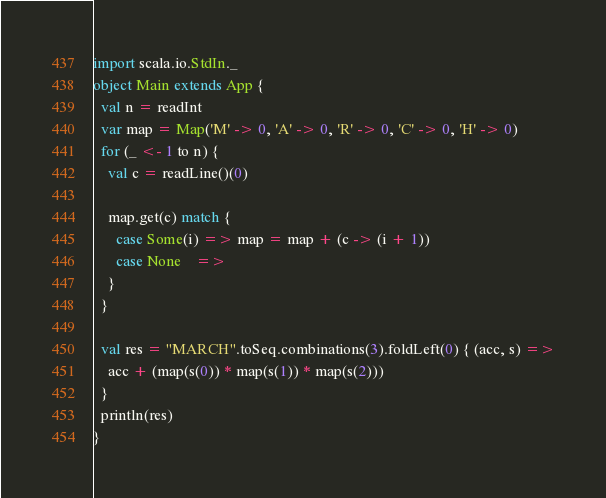<code> <loc_0><loc_0><loc_500><loc_500><_Scala_>import scala.io.StdIn._
object Main extends App {
  val n = readInt
  var map = Map('M' -> 0, 'A' -> 0, 'R' -> 0, 'C' -> 0, 'H' -> 0)
  for (_ <- 1 to n) {
    val c = readLine()(0)

    map.get(c) match {
      case Some(i) => map = map + (c -> (i + 1))
      case None    =>
    }
  }

  val res = "MARCH".toSeq.combinations(3).foldLeft(0) { (acc, s) =>
    acc + (map(s(0)) * map(s(1)) * map(s(2)))
  }
  println(res)
}
</code> 